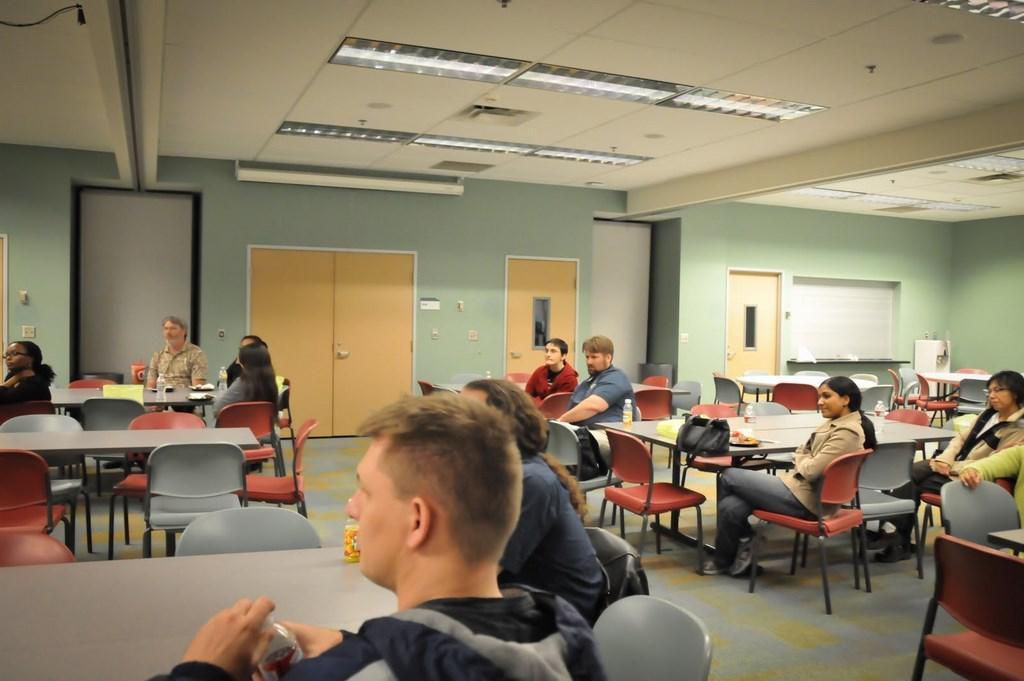What are the people in the image doing? The people in the image are sitting on chairs. What objects are present in the image that the people might be using? There are tables in the image that the people might be using. What can be seen in the background of the image? There is a wall visible in the image. What type of whip is being used by the person in the image? There is no whip present in the image. What is the cabbage used for in the image? There is no cabbage present in the image. 